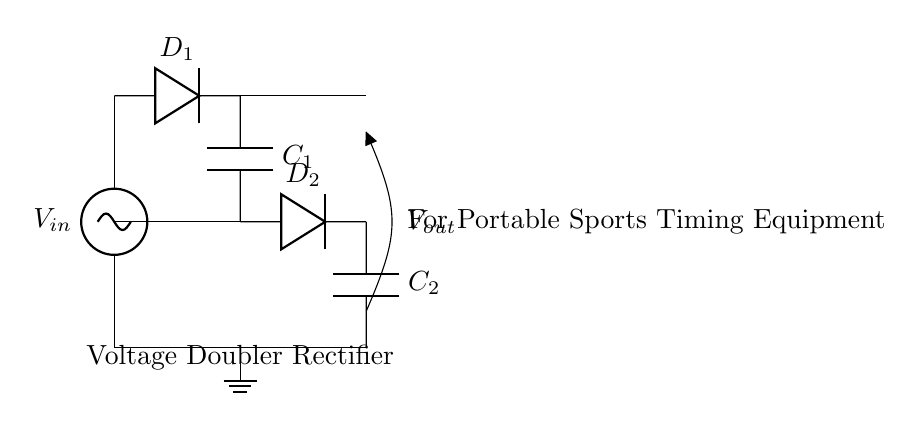What is the type of circuit shown? The circuit is identified as a voltage doubler rectifier, which is indicated in the label within the diagram.
Answer: Voltage doubler rectifier How many capacitors are present in this circuit? There are two capacitors labeled as C1 and C2 in the circuit diagram, which can be counted directly.
Answer: Two What is the role of diode D1 in the circuit? Diode D1 is used to allow current to flow in one direction, converting the AC input voltage into a pulsating DC, which is a fundamental aspect of rectification.
Answer: Rectification What is the output voltage compared to the input voltage? A voltage doubler rectifier is designed to provide an output voltage that is approximately double the input voltage under ideal conditions, as seen in the function of the circuit.
Answer: Double What happens to the output voltage if one of the diodes fails? If either diode D1 or D2 fails, the circuit will not function properly, resulting in a significant reduction or complete loss of the output voltage since the rectifying action is compromised.
Answer: Loss of output What is connected at the output of the circuit? The output is connected to a point designated as Vout, indicated in the circuit diagram, where the rectified voltage is taken.
Answer: Vout How do the capacitors affect the output voltage? The capacitors C1 and C2 store charge, smoothing out the pulsating DC voltage by providing charge during the gaps in rectified voltage, improving the stability of the output.
Answer: Smoothing 